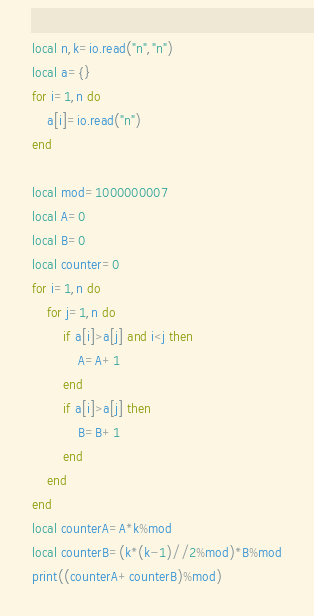Convert code to text. <code><loc_0><loc_0><loc_500><loc_500><_Lua_>local n,k=io.read("n","n")
local a={}
for i=1,n do
    a[i]=io.read("n")
end

local mod=1000000007
local A=0
local B=0
local counter=0
for i=1,n do
    for j=1,n do
        if a[i]>a[j] and i<j then
            A=A+1
        end
        if a[i]>a[j] then
            B=B+1
        end
    end
end
local counterA=A*k%mod
local counterB=(k*(k-1)//2%mod)*B%mod
print((counterA+counterB)%mod)</code> 